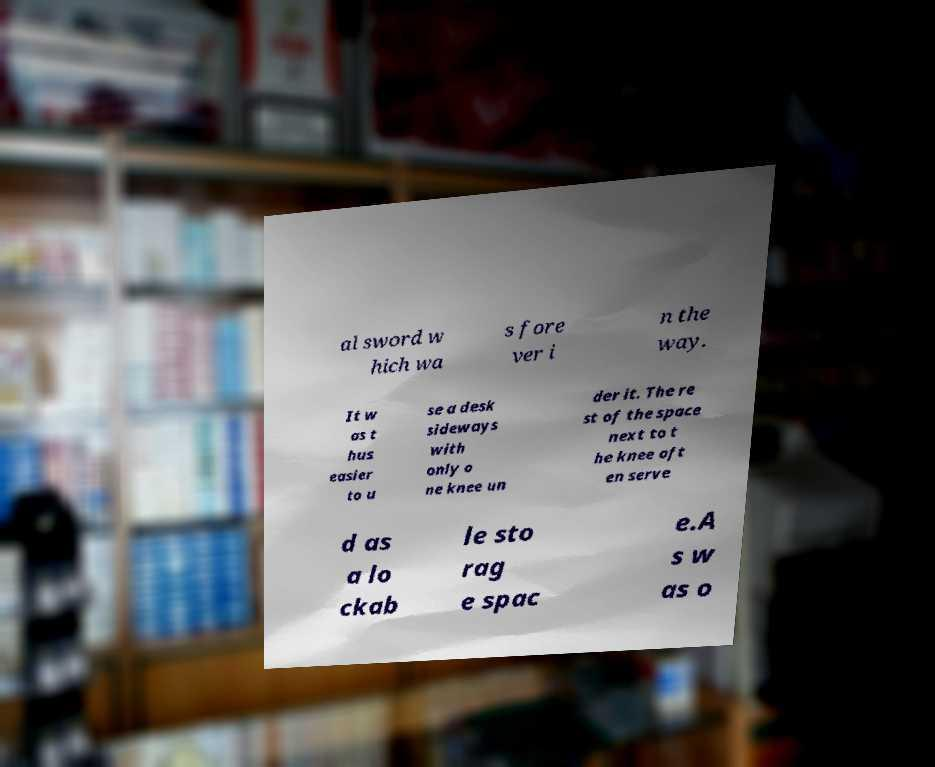For documentation purposes, I need the text within this image transcribed. Could you provide that? al sword w hich wa s fore ver i n the way. It w as t hus easier to u se a desk sideways with only o ne knee un der it. The re st of the space next to t he knee oft en serve d as a lo ckab le sto rag e spac e.A s w as o 